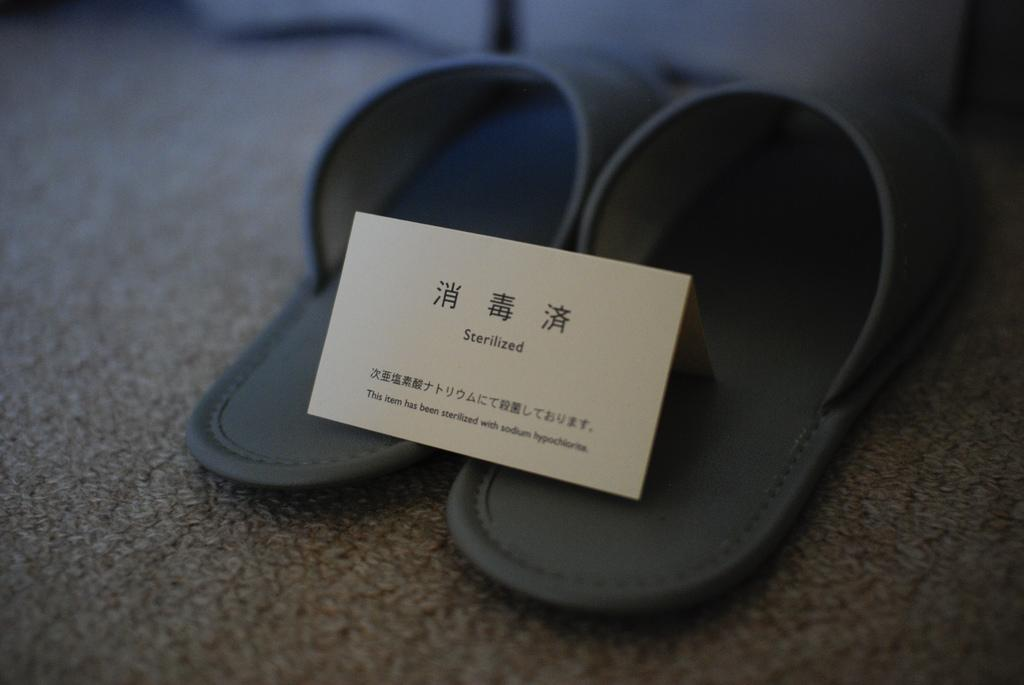What is placed on top of the footwear in the image? There is a card on footwear in the image. What type of surface is the footwear placed on? The footwear is on a carpet. How many spiders are crawling on the card in the image? There are no spiders present in the image. What is the plot of the story depicted on the card in the image? The card does not depict a story, so there is no plot to describe. 